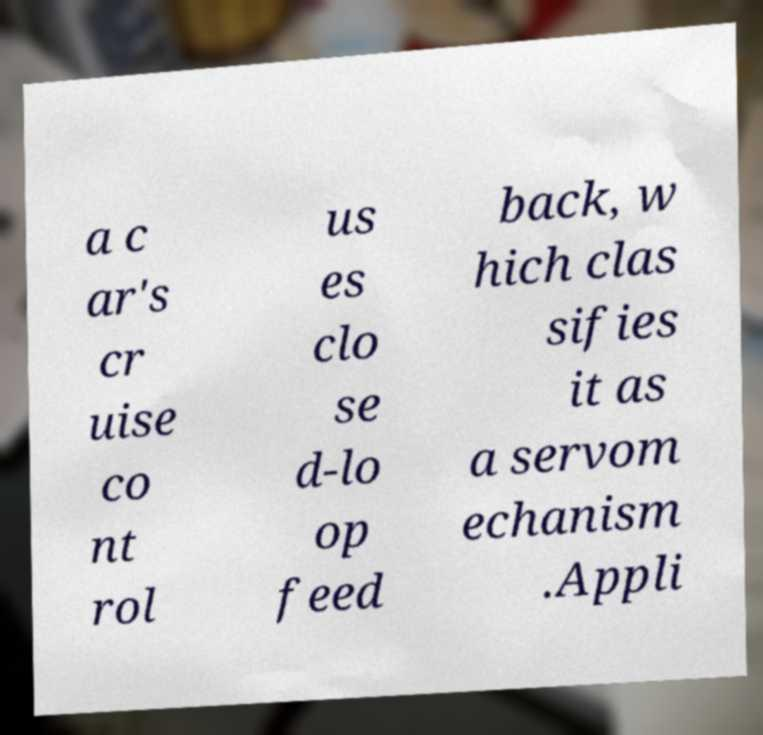For documentation purposes, I need the text within this image transcribed. Could you provide that? a c ar's cr uise co nt rol us es clo se d-lo op feed back, w hich clas sifies it as a servom echanism .Appli 